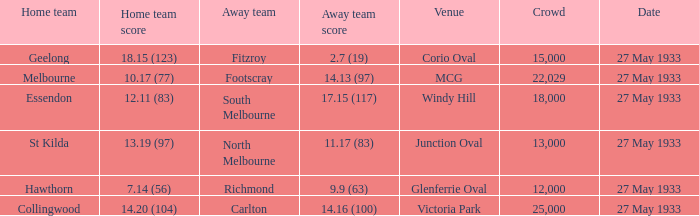In the event where the home team reached 1 25000.0. 